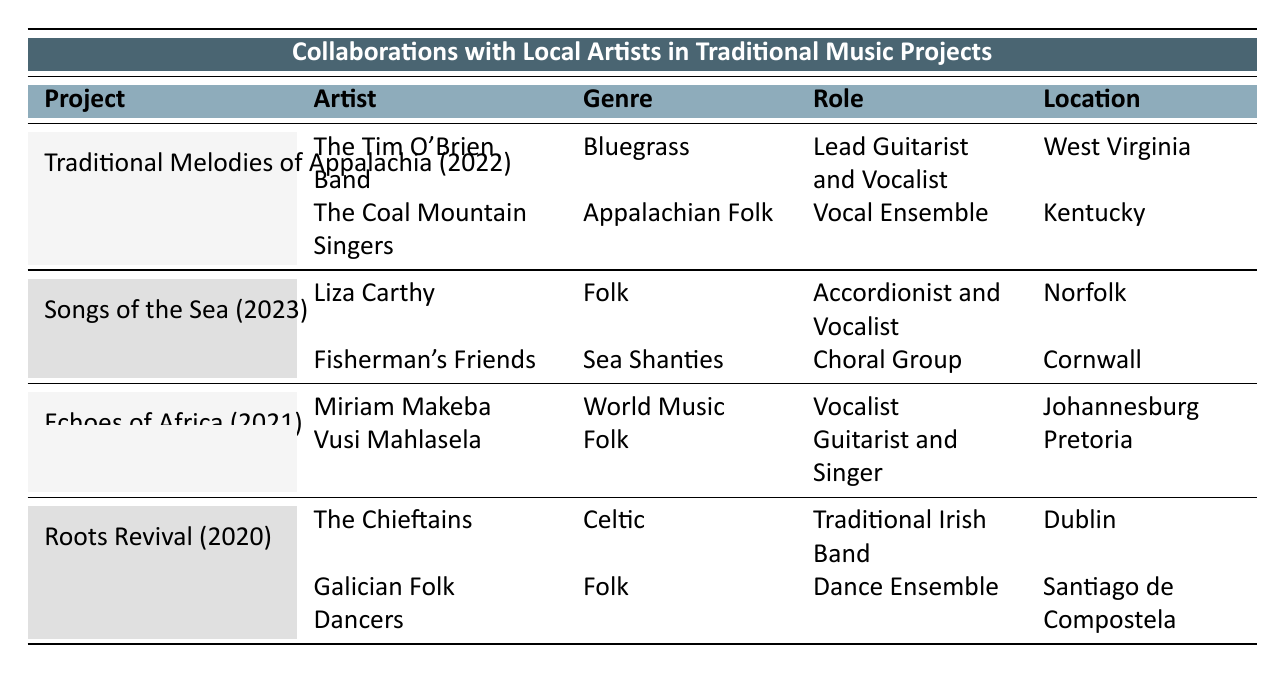What year was the project "Traditional Melodies of Appalachia" conducted? The table lists "Traditional Melodies of Appalachia" under the year 2022.
Answer: 2022 Which artists collaborated on the "Songs of the Sea" project? The table shows that "Songs of the Sea" featured Liza Carthy and Fisherman's Friends.
Answer: Liza Carthy and Fisherman's Friends What is the role of The Chieftains in the project "Roots Revival"? According to the table, The Chieftains are designated as a "Traditional Irish Band" in the "Roots Revival" project.
Answer: Traditional Irish Band Did any project include artists from both Africa and the UK? The "Echoes of Africa" project features artists from Africa, while "Songs of the Sea" includes artists from the UK. However, they are separate projects, not combined.
Answer: No Which genre is represented by the artist Vusi Mahlasela? The table indicates that Vusi Mahlasela is associated with the genre "Folk."
Answer: Folk How many projects listed in the table featured performances in 2023? The table shows that only the "Songs of the Sea" project is from 2023, indicating just one project for that year.
Answer: 1 What is the total number of artists mentioned across all projects? By counting the artists listed for each project, we find 2 artists for each of the 4 projects, totaling 8 artists across all projects.
Answer: 8 Is there any artist located in West Virginia? The table states that The Tim O'Brien Band, located in West Virginia, participated in the project "Traditional Melodies of Appalachia."
Answer: Yes Which traditional music project has a focus on sea shanties? The "Songs of the Sea" project specifically aims to revive traditional sea shanties, as mentioned in the description.
Answer: Songs of the Sea 